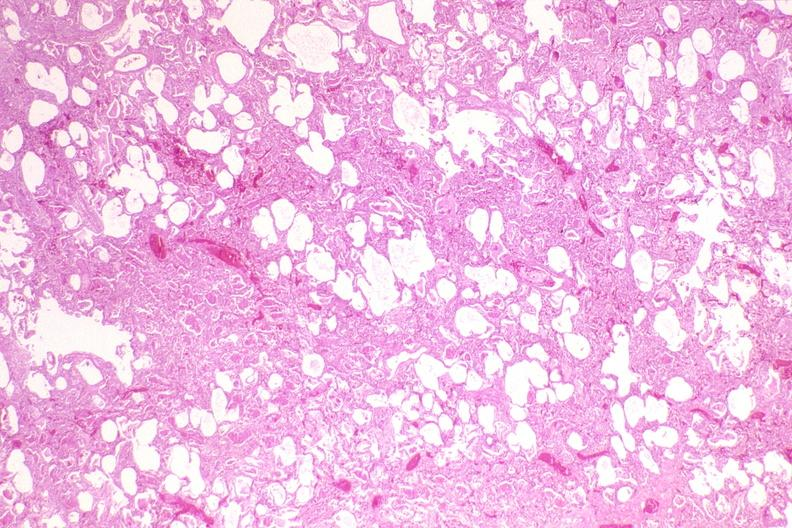does this image show lung, pneumocystis pneumonia?
Answer the question using a single word or phrase. Yes 